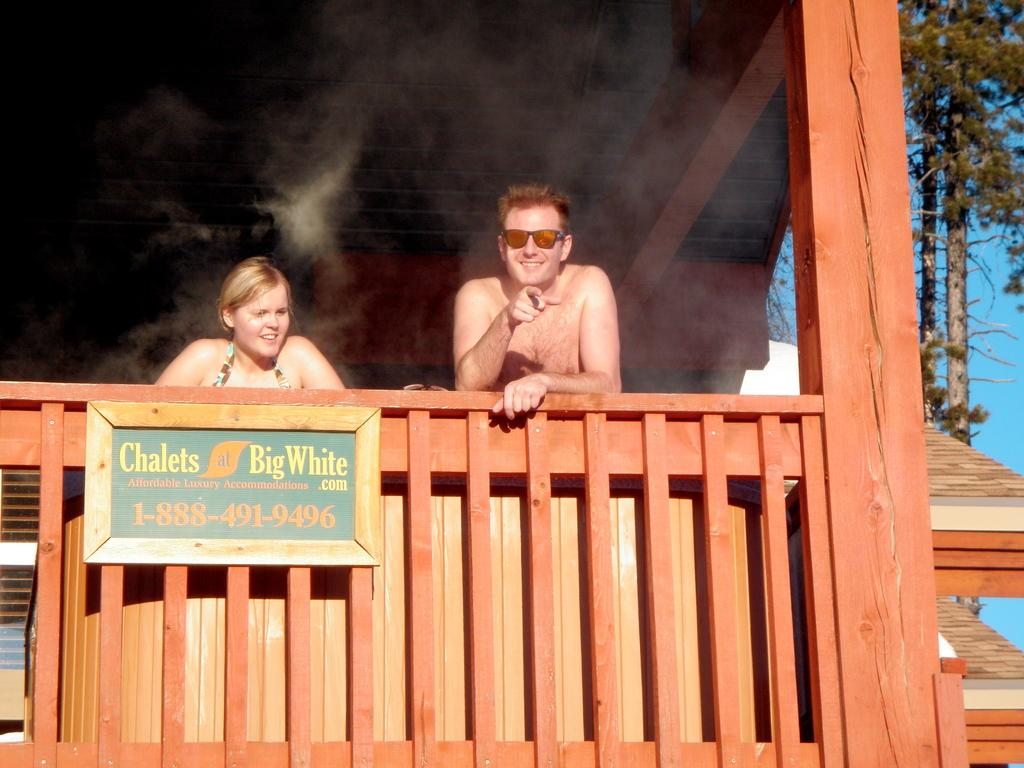How many people are inside the house in the image? There are two people standing inside the house in the image. What is attached to the wooden railing in the image? There is a board attached to a wooden railing in the image. What type of vegetation can be seen to the right of the image? Trees are visible to the right of the image. What color is the sky in the image? The sky is blue in the image. What type of jeans is the person on the left wearing in the image? There is no information about the clothing of the people in the image, so we cannot determine if they are wearing jeans or any other type of clothing. What is the stage used for in the image? There is no stage present in the image. 